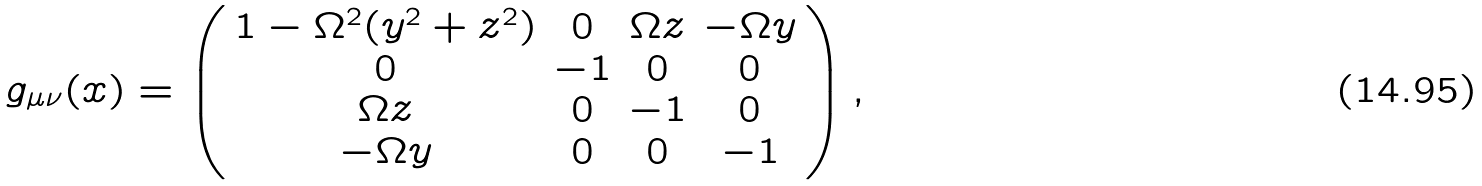Convert formula to latex. <formula><loc_0><loc_0><loc_500><loc_500>g _ { \mu \nu } ( x ) = \left ( \begin{array} { c c c c } 1 - \Omega ^ { 2 } ( y ^ { 2 } + z ^ { 2 } ) & 0 & \Omega z & - \Omega y \\ 0 & - 1 & 0 & 0 \\ \Omega z & 0 & - 1 & 0 \\ - \Omega y & 0 & 0 & - 1 \end{array} \right ) ,</formula> 